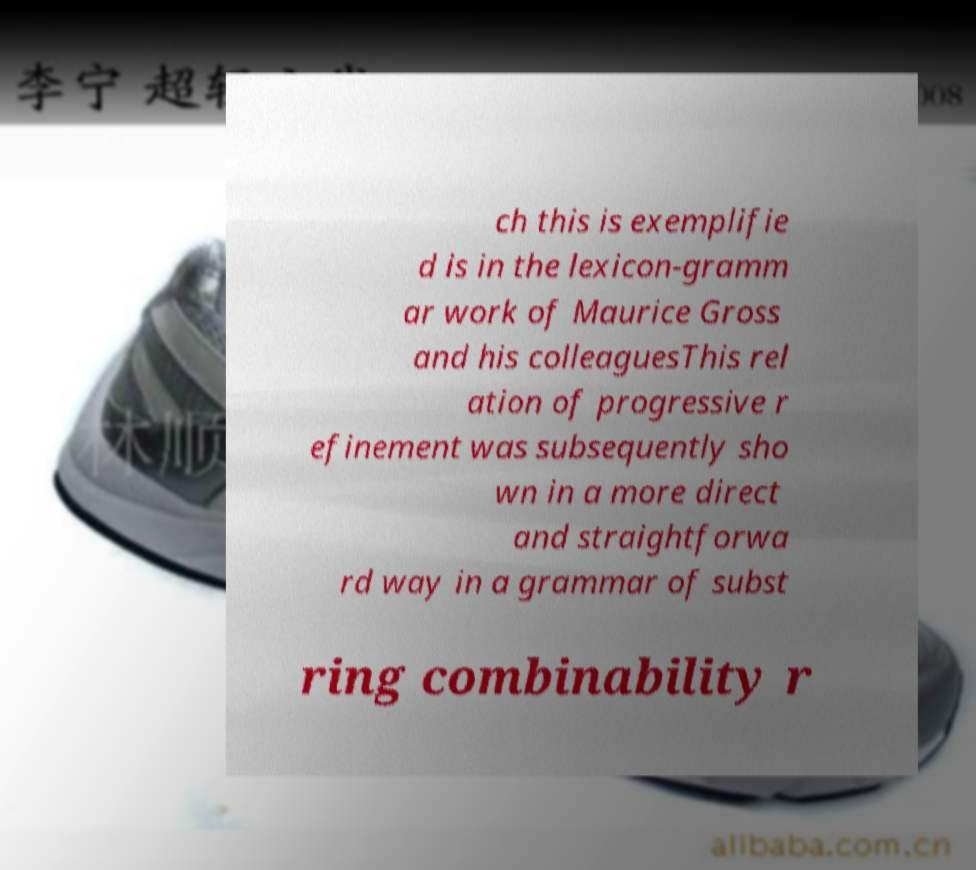Could you extract and type out the text from this image? ch this is exemplifie d is in the lexicon-gramm ar work of Maurice Gross and his colleaguesThis rel ation of progressive r efinement was subsequently sho wn in a more direct and straightforwa rd way in a grammar of subst ring combinability r 